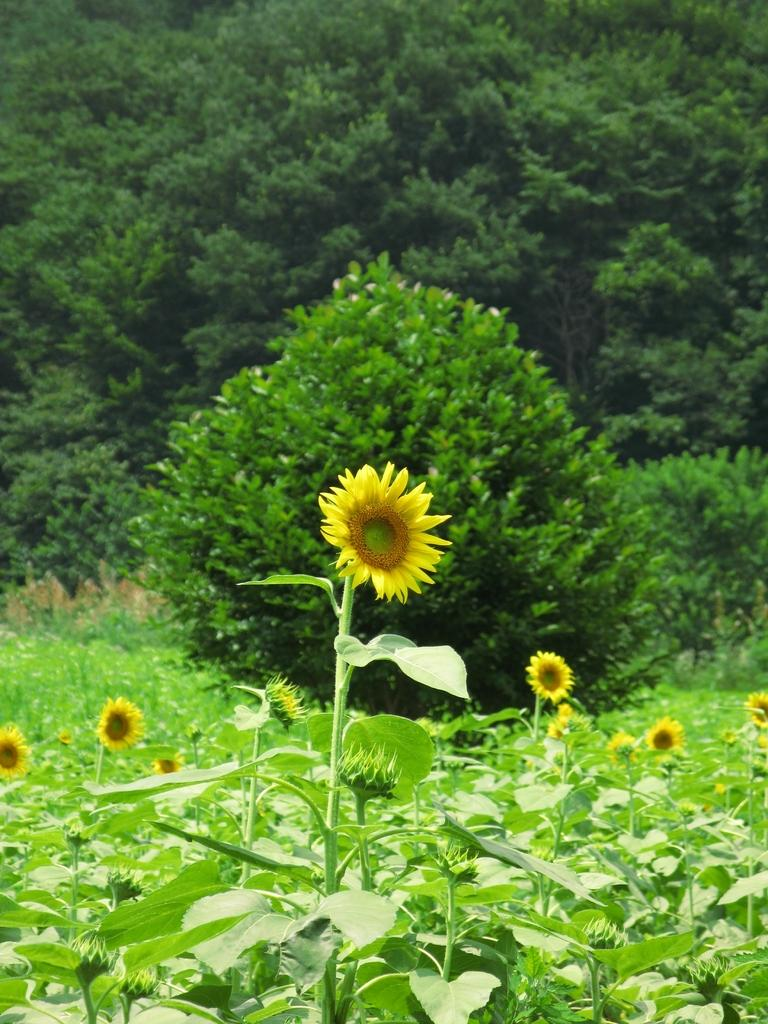What type of flora can be seen in the image? There are flowers and plants in the image. Can you describe the background of the image? There are trees in the background of the image. What type of lunch is being served in the image? There is no lunch present in the image; it features flowers, plants, and trees. How many dogs can be seen in the image? There are no dogs present in the image. 